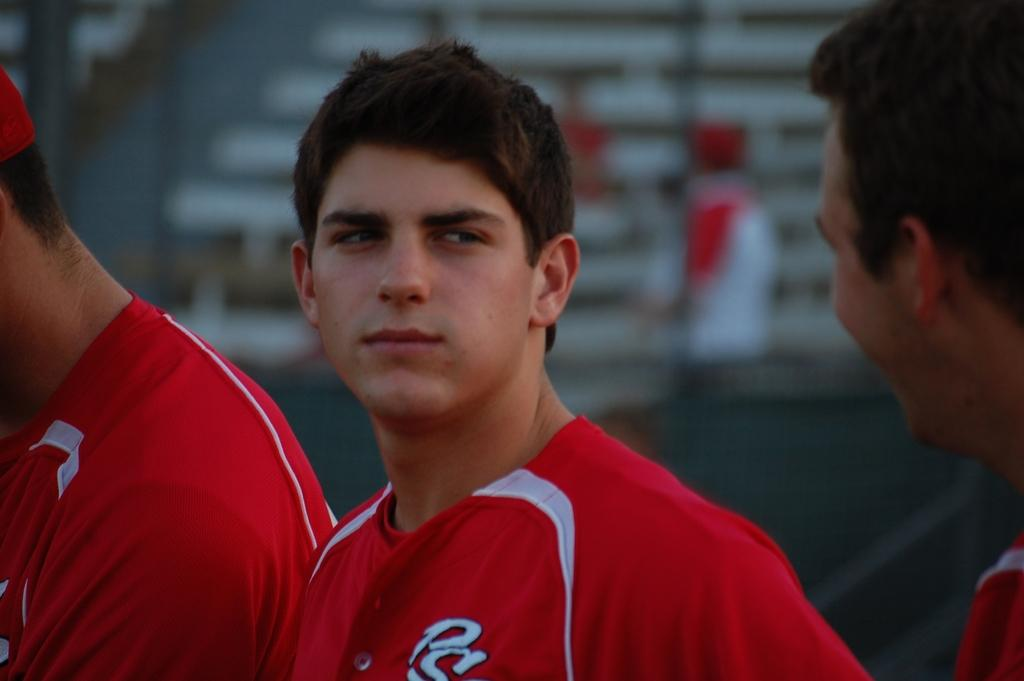How many people are in the image? There are three persons in the image. What are the people wearing? Each person is wearing a red color t-shirt. Can you describe the background of the image? The background of the image is blurred. What type of fiction is the person holding in the image? There is no fiction present in the image; the people are wearing red t-shirts and standing in a blurred background. What mark can be seen on the person's forehead in the image? There are no marks visible on any of the persons' foreheads in the image. 